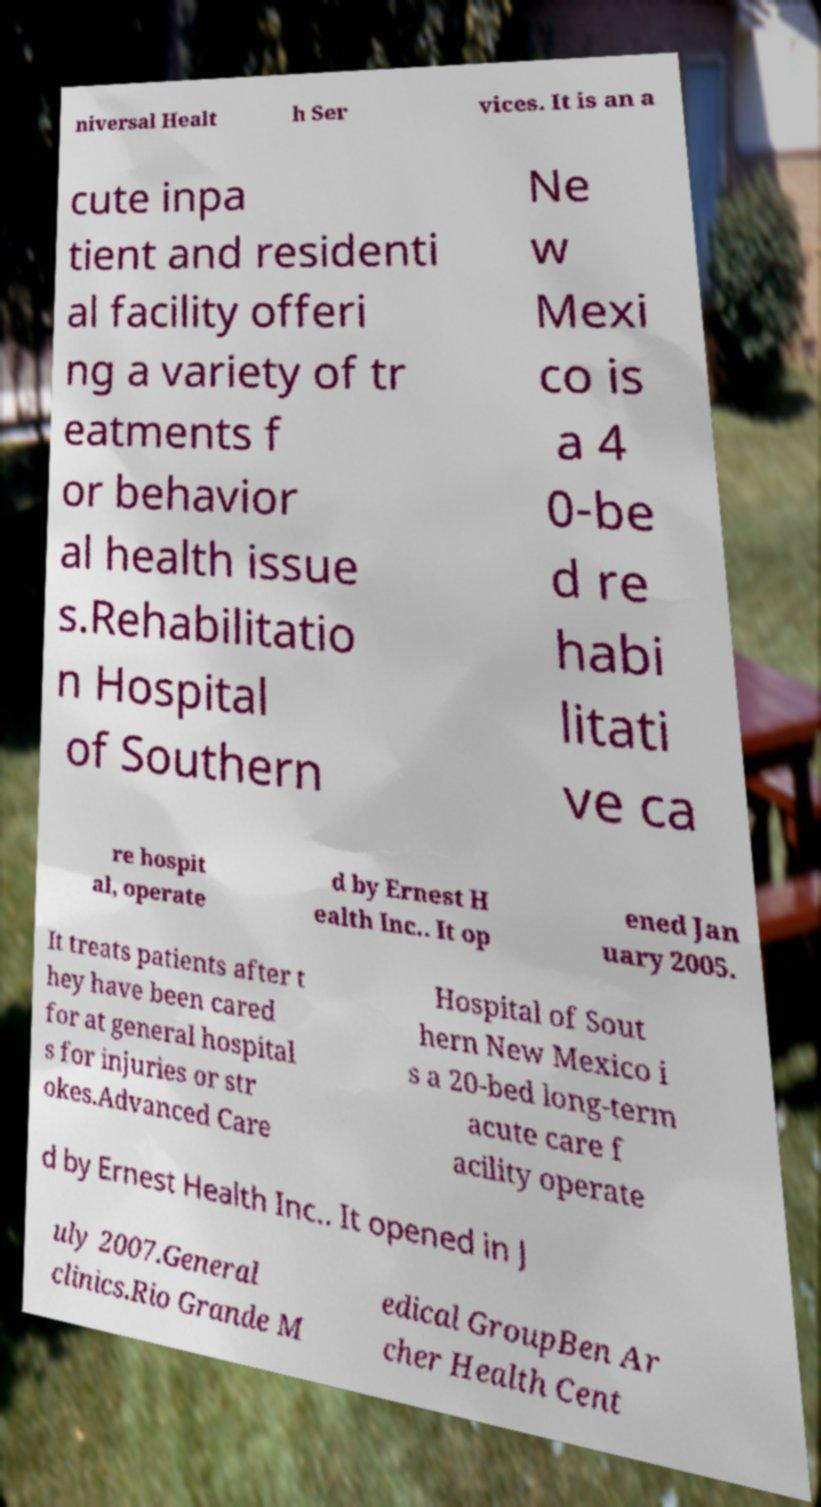I need the written content from this picture converted into text. Can you do that? niversal Healt h Ser vices. It is an a cute inpa tient and residenti al facility offeri ng a variety of tr eatments f or behavior al health issue s.Rehabilitatio n Hospital of Southern Ne w Mexi co is a 4 0-be d re habi litati ve ca re hospit al, operate d by Ernest H ealth Inc.. It op ened Jan uary 2005. It treats patients after t hey have been cared for at general hospital s for injuries or str okes.Advanced Care Hospital of Sout hern New Mexico i s a 20-bed long-term acute care f acility operate d by Ernest Health Inc.. It opened in J uly 2007.General clinics.Rio Grande M edical GroupBen Ar cher Health Cent 